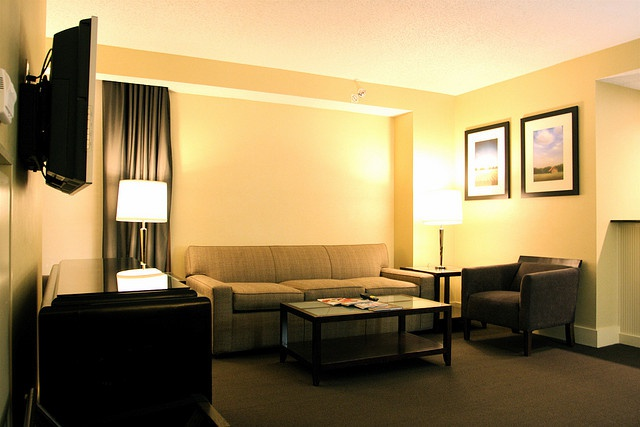Describe the objects in this image and their specific colors. I can see couch in tan, black, olive, and orange tones, chair in tan, black, maroon, and gray tones, tv in tan and black tones, dining table in tan, black, and olive tones, and book in tan, orange, red, and brown tones in this image. 